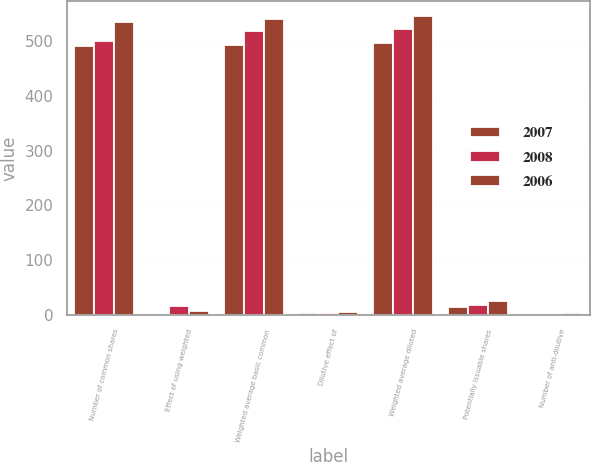Convert chart to OTSL. <chart><loc_0><loc_0><loc_500><loc_500><stacked_bar_chart><ecel><fcel>Number of common shares<fcel>Effect of using weighted<fcel>Weighted average basic common<fcel>Dilutive effect of<fcel>Weighted average diluted<fcel>Potentially issuable shares<fcel>Number of anti-dilutive<nl><fcel>2007<fcel>490.7<fcel>1.4<fcel>492.1<fcel>3.3<fcel>495.4<fcel>15.1<fcel>0.8<nl><fcel>2008<fcel>500.1<fcel>17.2<fcel>517.3<fcel>4.5<fcel>521.8<fcel>18.2<fcel>2.4<nl><fcel>2006<fcel>533.7<fcel>6.7<fcel>540.4<fcel>5.7<fcel>546.1<fcel>26<fcel>4.6<nl></chart> 